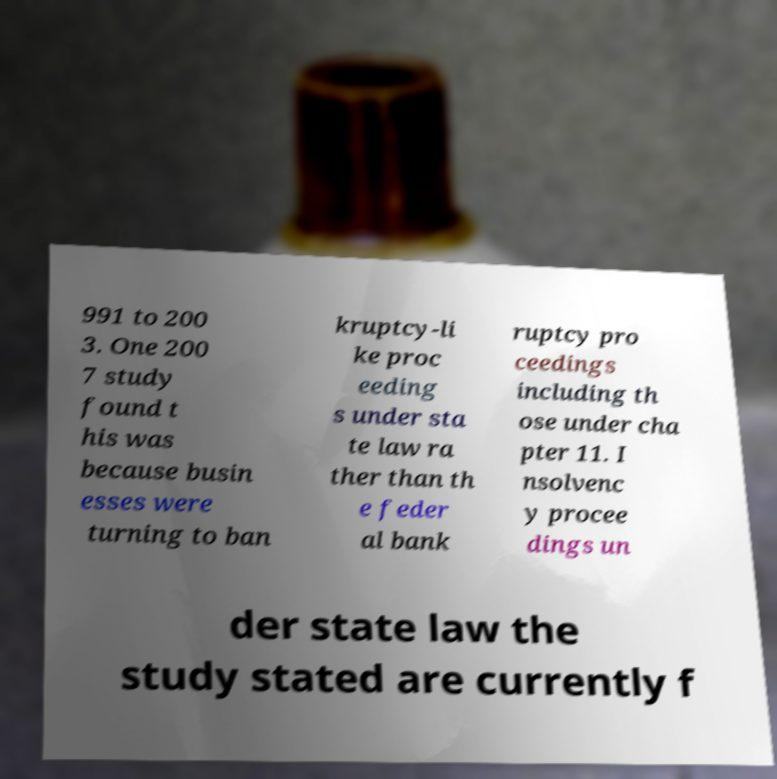Could you assist in decoding the text presented in this image and type it out clearly? 991 to 200 3. One 200 7 study found t his was because busin esses were turning to ban kruptcy-li ke proc eeding s under sta te law ra ther than th e feder al bank ruptcy pro ceedings including th ose under cha pter 11. I nsolvenc y procee dings un der state law the study stated are currently f 